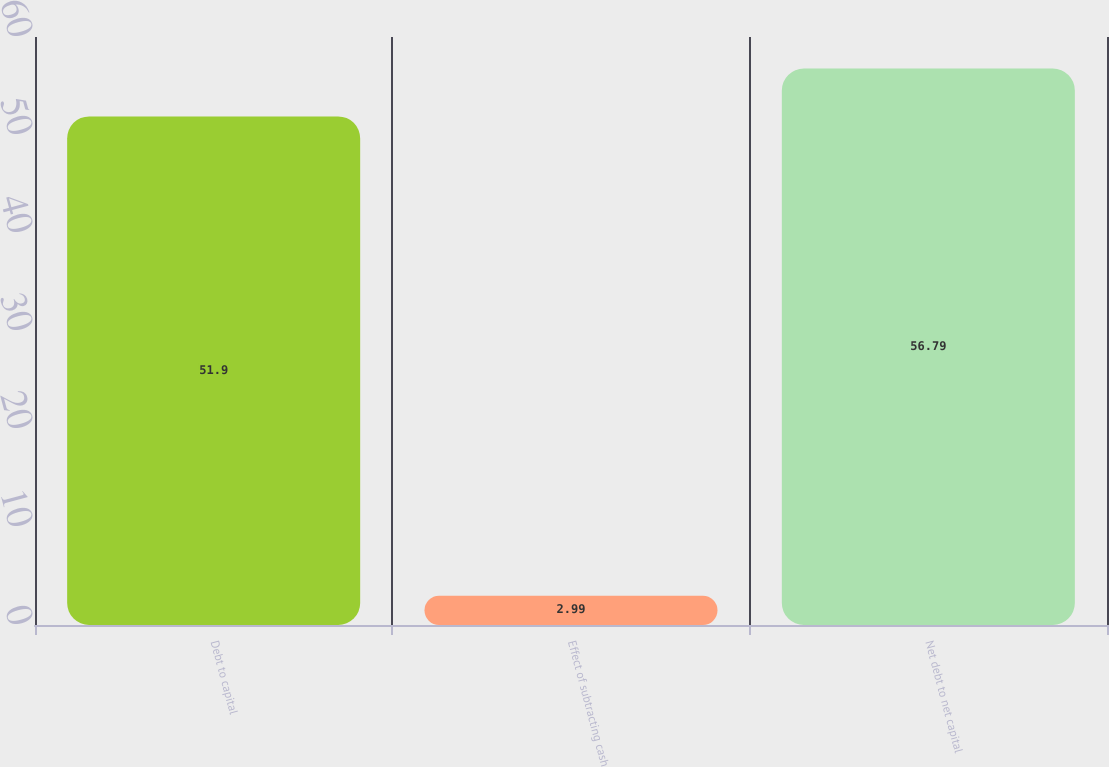Convert chart to OTSL. <chart><loc_0><loc_0><loc_500><loc_500><bar_chart><fcel>Debt to capital<fcel>Effect of subtracting cash<fcel>Net debt to net capital<nl><fcel>51.9<fcel>2.99<fcel>56.79<nl></chart> 